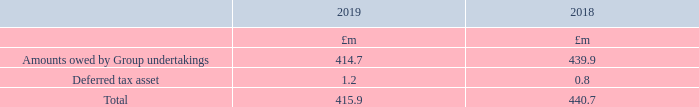4. Debtors
Amounts owed by Group undertakings are non-interest-bearing, unsecured and have no fixed date of repayment.
What characteristics do amounts owed by Group undertakings possess? Non-interest-bearing, unsecured and have no fixed date of repayment. What was the total amount owed to debtors by the Group in 2019?
Answer scale should be: million. 415.9. What are the components factored in when calculating the total amount owed to debtors in the table? Amounts owed by group undertakings, deferred tax asset. In which year was the Deferred tax asset larger? 1.2>0.8
Answer: 2019. What was the change in deferred tax asset in 2019 from 2018?
Answer scale should be: million. 1.2-0.8
Answer: 0.4. What was the percentage change in deferred tax asset in 2019 from 2018?
Answer scale should be: percent. (1.2-0.8)/0.8
Answer: 50. 